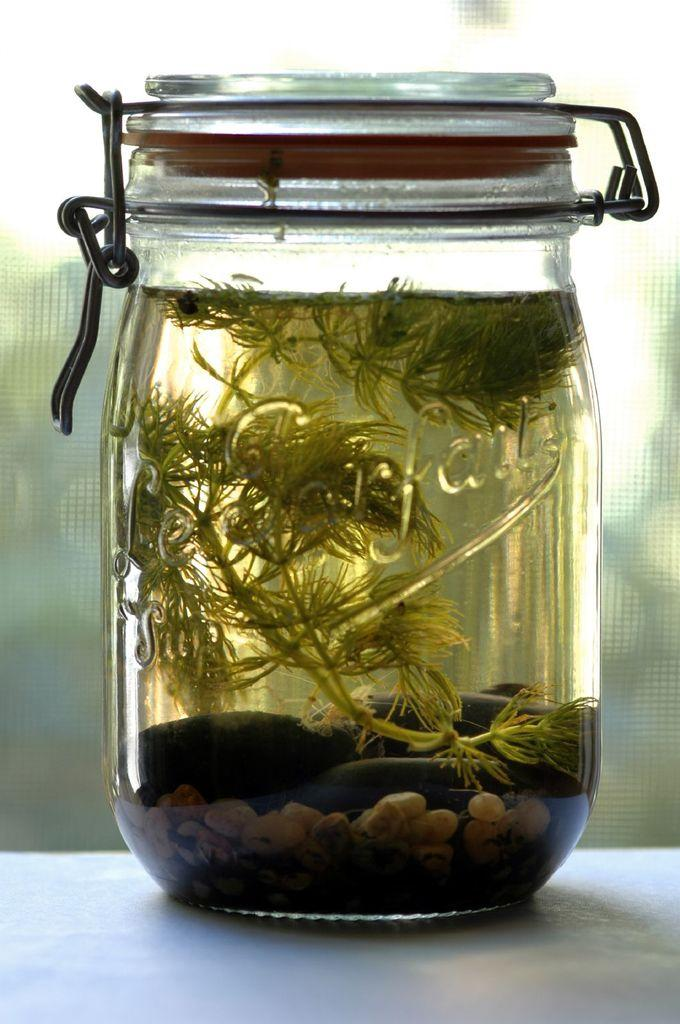What object is present in the image? There is a jar in the image. Where is the jar located? The jar is on a surface. What is inside the jar? There are leaves, water, and stones in the jar. Can you describe the background of the image? The background of the image is blurry. What type of desk can be seen in the image? There is no desk present in the image; it features a jar with leaves, water, and stones. What color is the sheet wrapped around the coil in the image? There is no sheet or coil present in the image. 